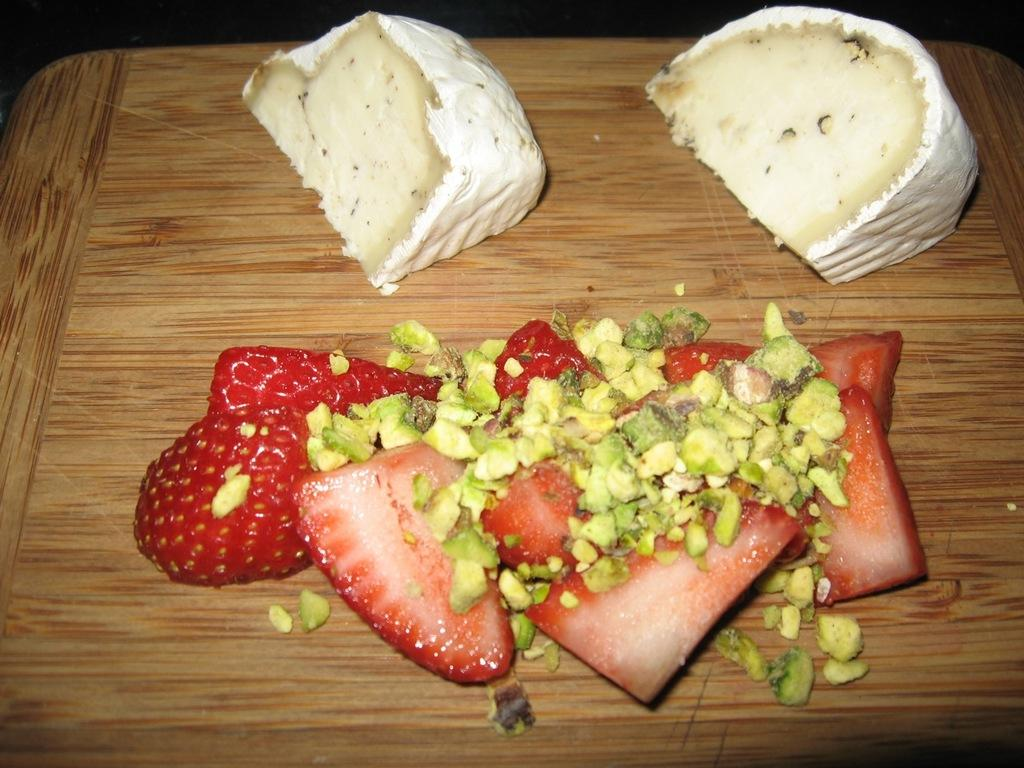What type of fruit can be seen in the image? There are strawberries in the image. What type of dessert is present in the image? There are cakes in the image. What items might be used for cooking or baking in the image? There are ingredients visible in the image. What material is the object made of in the image? The wooden object is present in the image. How does the growth of the strawberries affect the icicle formation in the image? There is no icicle present in the image, and the growth of the strawberries does not affect any icicle formation. 